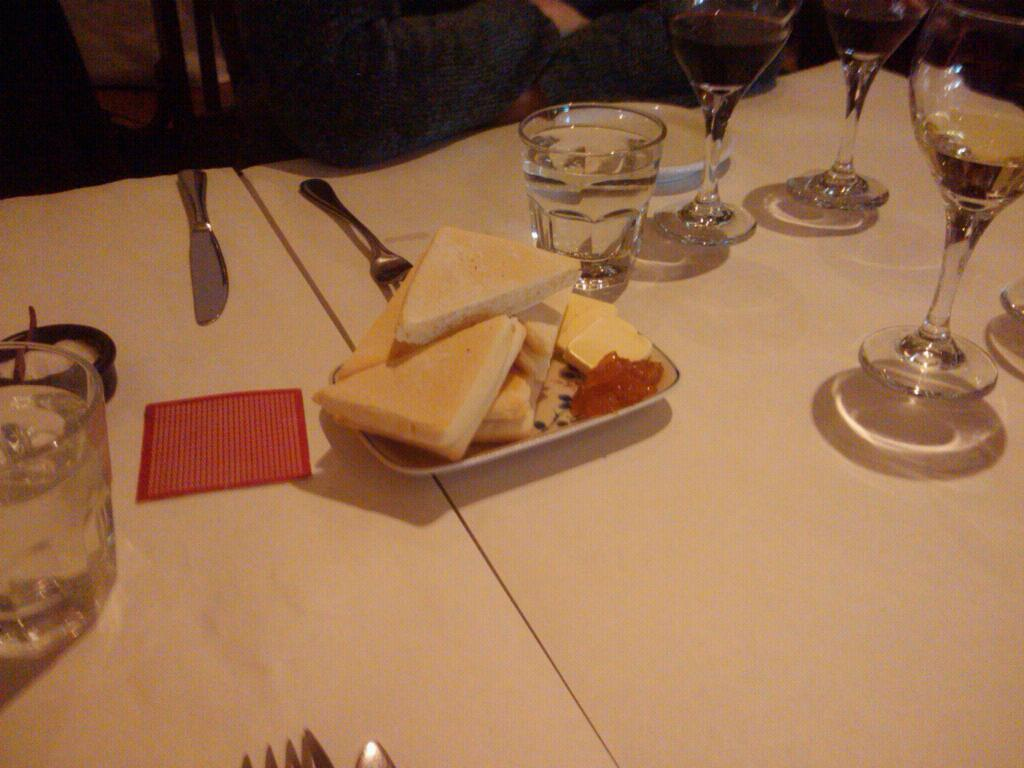What type of glasses can be seen in the image? There are water glasses and wine glasses in the image. What utensils are present in the image? There are forks and knives in the image. What is on the table in the image? There is food on the table in the image. Can you describe the person's position in relation to the table? A person is sitting near the table, and their hand is on the table. What type of collar is the person wearing in the image? There is no collar visible in the image, as the person's clothing is not described. How many hands does the person have on the table in the image? The person has one hand on the table in the image. 